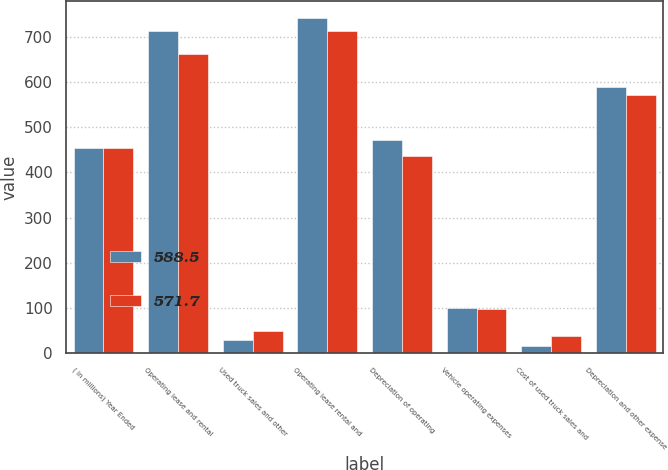Convert chart. <chart><loc_0><loc_0><loc_500><loc_500><stacked_bar_chart><ecel><fcel>( in millions) Year Ended<fcel>Operating lease and rental<fcel>Used truck sales and other<fcel>Operating lease rental and<fcel>Depreciation of operating<fcel>Vehicle operating expenses<fcel>Cost of used truck sales and<fcel>Depreciation and other expense<nl><fcel>588.5<fcel>453.85<fcel>712.2<fcel>29.4<fcel>741.6<fcel>472.3<fcel>100.6<fcel>15.6<fcel>588.5<nl><fcel>571.7<fcel>453.85<fcel>663<fcel>49.1<fcel>712.1<fcel>435.4<fcel>98.1<fcel>38.2<fcel>571.7<nl></chart> 